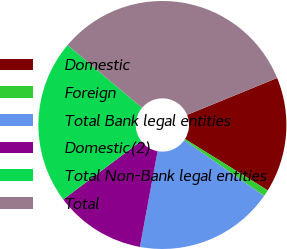<chart> <loc_0><loc_0><loc_500><loc_500><pie_chart><fcel>Domestic<fcel>Foreign<fcel>Total Bank legal entities<fcel>Domestic(2)<fcel>Total Non-Bank legal entities<fcel>Total<nl><fcel>15.03%<fcel>0.85%<fcel>18.21%<fcel>11.85%<fcel>21.39%<fcel>32.67%<nl></chart> 